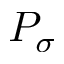Convert formula to latex. <formula><loc_0><loc_0><loc_500><loc_500>P _ { \sigma }</formula> 